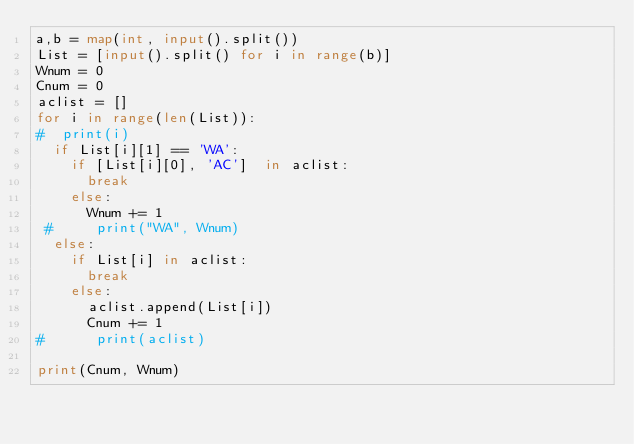Convert code to text. <code><loc_0><loc_0><loc_500><loc_500><_Python_>a,b = map(int, input().split())
List = [input().split() for i in range(b)]
Wnum = 0
Cnum = 0
aclist = []
for i in range(len(List)):
#  print(i)
  if List[i][1] == 'WA':
    if [List[i][0], 'AC']  in aclist:
      break
    else:
      Wnum += 1
 #     print("WA", Wnum)
  else:
    if List[i] in aclist:
      break
    else:
      aclist.append(List[i])
      Cnum += 1
#      print(aclist)

print(Cnum, Wnum)

</code> 